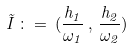<formula> <loc_0><loc_0><loc_500><loc_500>\vec { I } \, \colon = \, ( \frac { h _ { 1 } } { \omega _ { 1 } } \, , \, \frac { h _ { 2 } } { \omega _ { 2 } } )</formula> 